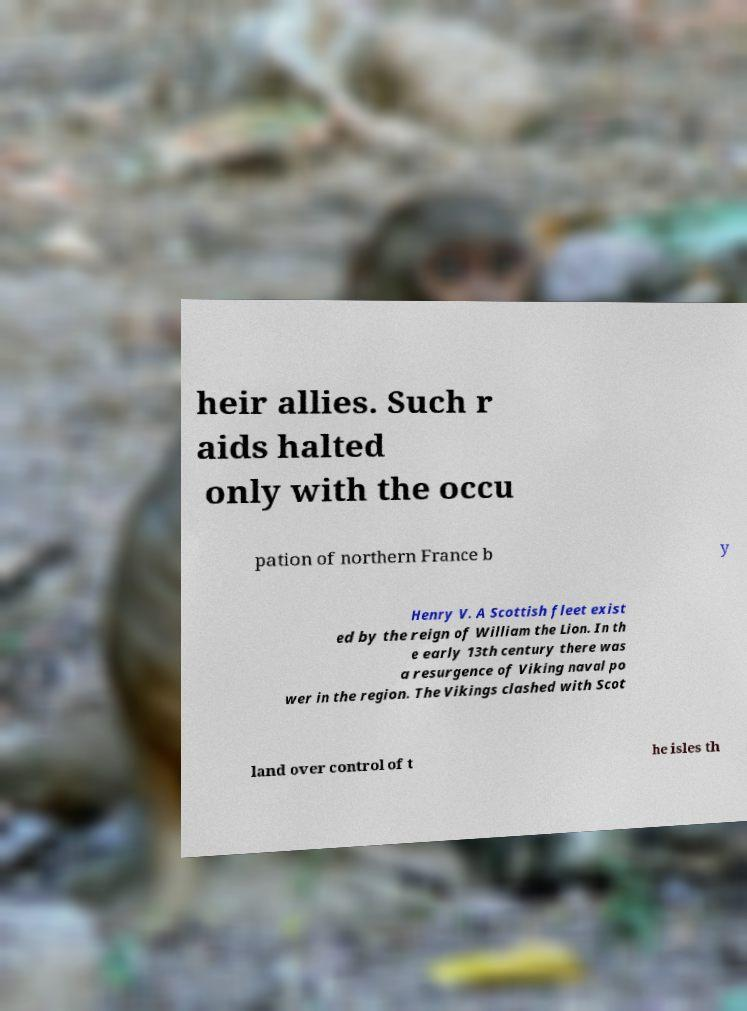Could you extract and type out the text from this image? heir allies. Such r aids halted only with the occu pation of northern France b y Henry V. A Scottish fleet exist ed by the reign of William the Lion. In th e early 13th century there was a resurgence of Viking naval po wer in the region. The Vikings clashed with Scot land over control of t he isles th 